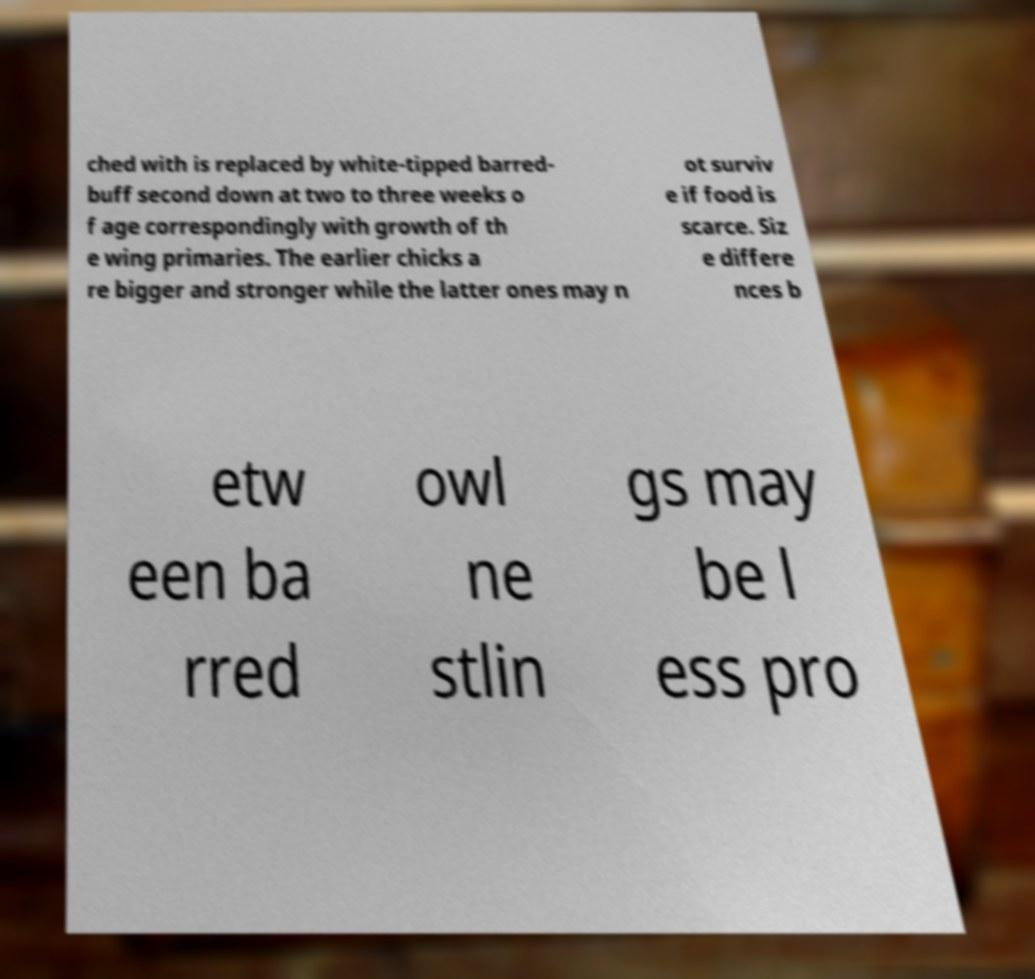Could you extract and type out the text from this image? ched with is replaced by white-tipped barred- buff second down at two to three weeks o f age correspondingly with growth of th e wing primaries. The earlier chicks a re bigger and stronger while the latter ones may n ot surviv e if food is scarce. Siz e differe nces b etw een ba rred owl ne stlin gs may be l ess pro 